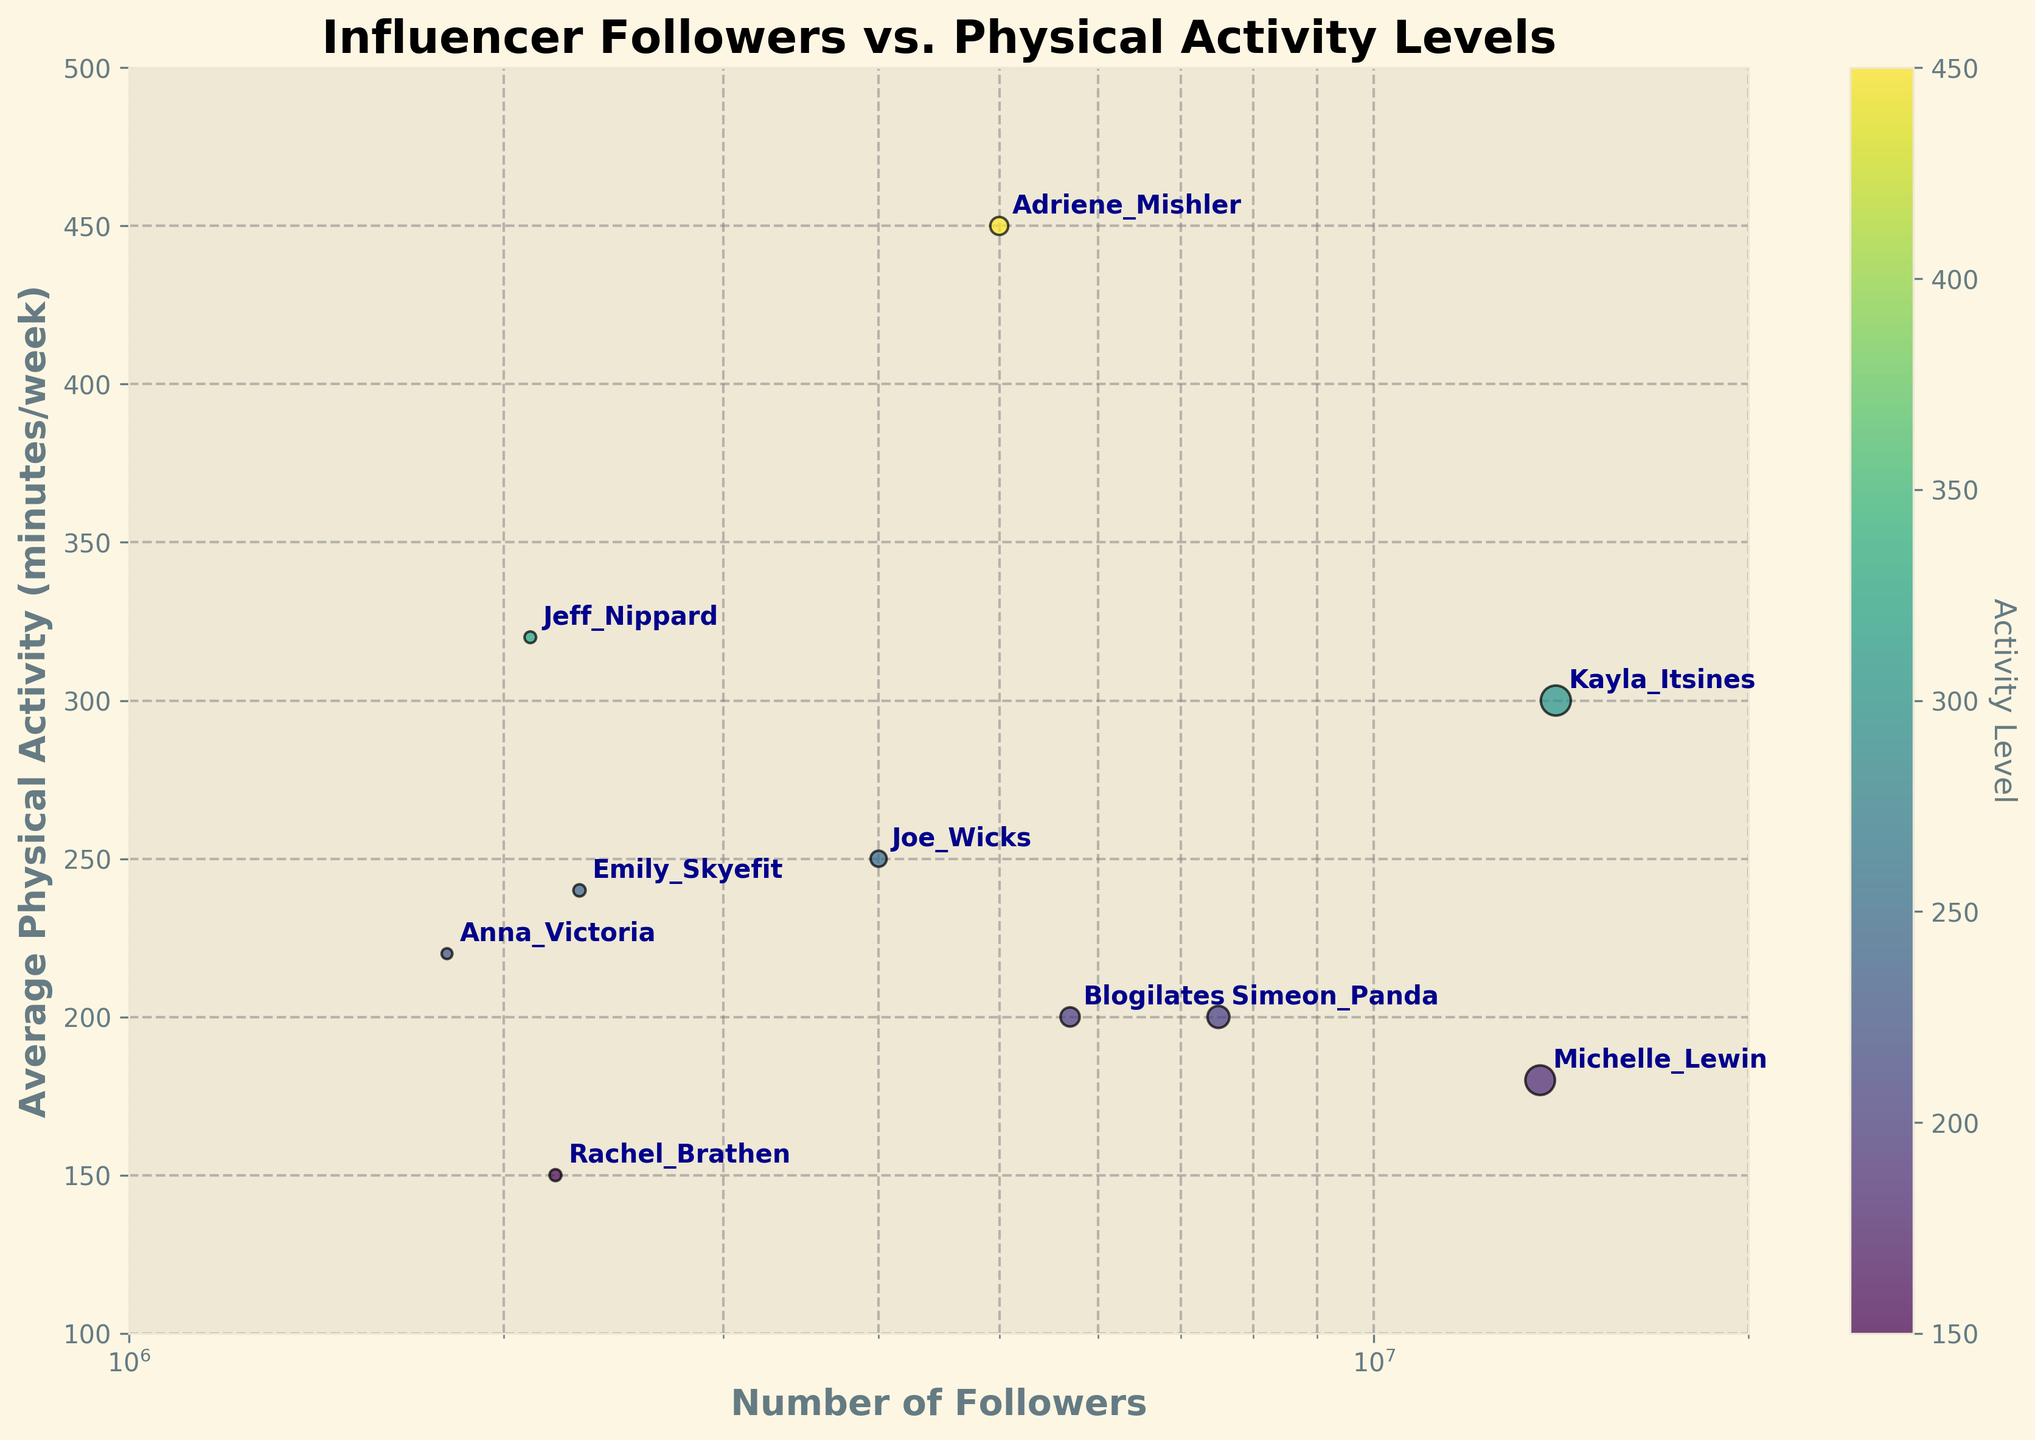How many influencers have more than 6 million followers? By looking at the x-axis and the log scale values, we count the influencers with follower counts greater than 6 million: Kayla Itsines, Simeon Panda, Michelle Lewin, and Blogilates.
Answer: 4 Which influencer has the highest average physical activity minutes per week? By observing the points on the y-axis, the influencer Adriene Mishler reaches the highest average physical activity level at 450 minutes per week.
Answer: Adriene Mishler Compare the average physical activity levels of Kayla Itsines and Joe Wicks. Who is more active? Kayla Itsines has an average of 300 minutes per week, whereas Joe Wicks has 250 minutes per week. Thus, Kayla Itsines is more active.
Answer: Kayla Itsines What is the relationship between followers and the size of the markers on the scatter plot? The marker size is proportional to the number of followers, meaning larger markers represent influencers with more followers.
Answer: Larger markers indicate more followers Which influencer has the smallest average physical activity level, and how many followers do they have? The influencer with the smallest average physical activity level is Rachel Brathen, with 150 minutes per week. Rachel Brathen has 2,200,000 followers.
Answer: Rachel Brathen, 2,200,000 Which influencer has more followers: Michelle Lewin or Jeff Nippard? By comparing their positions on the x-axis, Michelle Lewin has 13,600,000 followers, while Jeff Nippard has 2,100,000 followers. Thus Michelle Lewin has more followers.
Answer: Michelle Lewin What is the average physical activity level of influencers with less than 3 million followers? Influencers with less than 3 million followers and their activity levels are Anna Victoria (220), Jeff Nippard (320), Rachel Brathen (150), and Emily Skyefit (240). The average can be calculated as (220 + 320 + 150 + 240) / 4 = 232.5 minutes per week.
Answer: 232.5 Are there any influencers with more than 10 million followers but less than 200 minutes of physical activity per week? By checking the figure, Kayla Itsines and Michelle Lewin have more than 10 million followers. Michelle Lewin has 180 minutes per week, while Kayla Itsines is more active.
Answer: Yes, Michelle Lewin Which influencer has a similar average physical activity level to Blogilates? Blogilates has an average physical activity level of 200 minutes per week. Simeon Panda also has 200 minutes of physical activity per week, making them similar.
Answer: Simeon Panda 